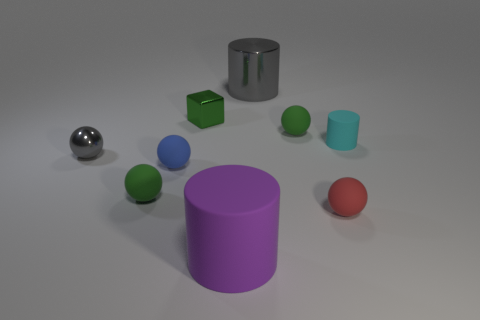Subtract all metal cylinders. How many cylinders are left? 2 Add 1 small blue rubber spheres. How many objects exist? 10 Subtract 4 spheres. How many spheres are left? 1 Subtract all cyan cylinders. How many cylinders are left? 2 Subtract all cubes. How many objects are left? 8 Subtract all yellow cylinders. Subtract all blue balls. How many cylinders are left? 3 Subtract all brown balls. How many cyan cylinders are left? 1 Subtract all big yellow rubber cylinders. Subtract all tiny cyan rubber cylinders. How many objects are left? 8 Add 6 purple matte cylinders. How many purple matte cylinders are left? 7 Add 7 tiny gray shiny balls. How many tiny gray shiny balls exist? 8 